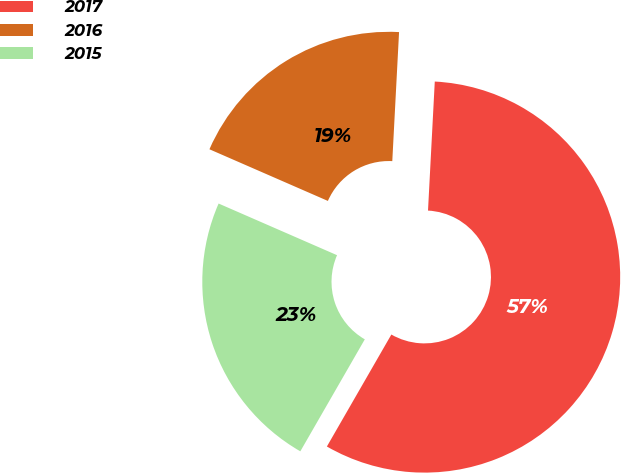Convert chart to OTSL. <chart><loc_0><loc_0><loc_500><loc_500><pie_chart><fcel>2017<fcel>2016<fcel>2015<nl><fcel>57.48%<fcel>19.29%<fcel>23.23%<nl></chart> 